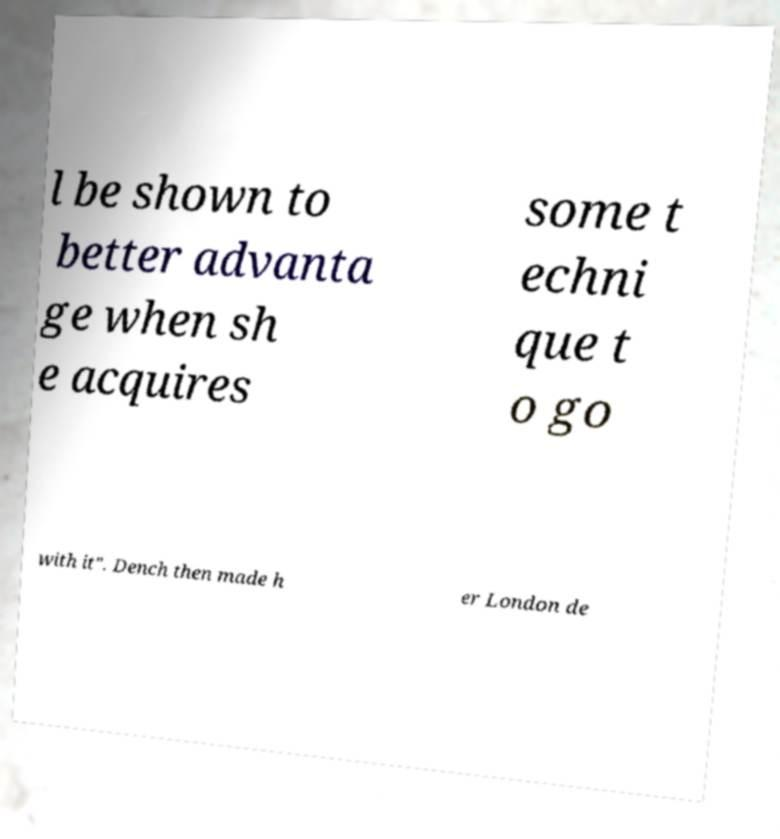I need the written content from this picture converted into text. Can you do that? l be shown to better advanta ge when sh e acquires some t echni que t o go with it". Dench then made h er London de 